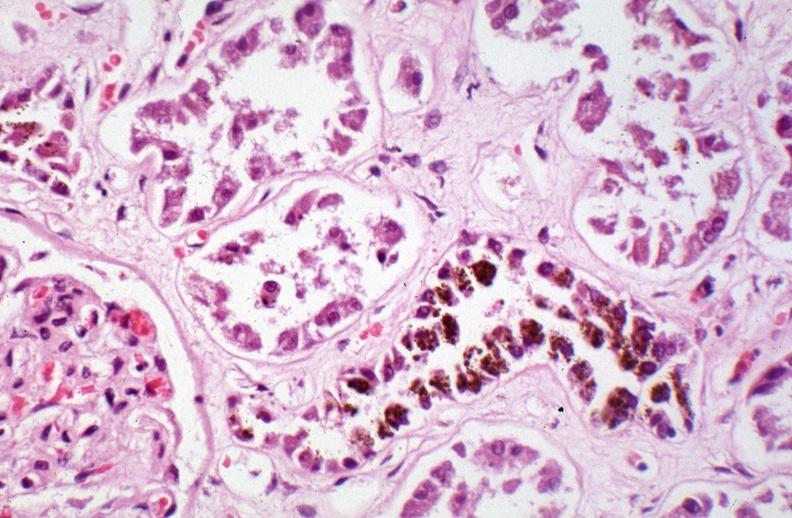does this image show kidney, chronic sickle cell disease?
Answer the question using a single word or phrase. Yes 